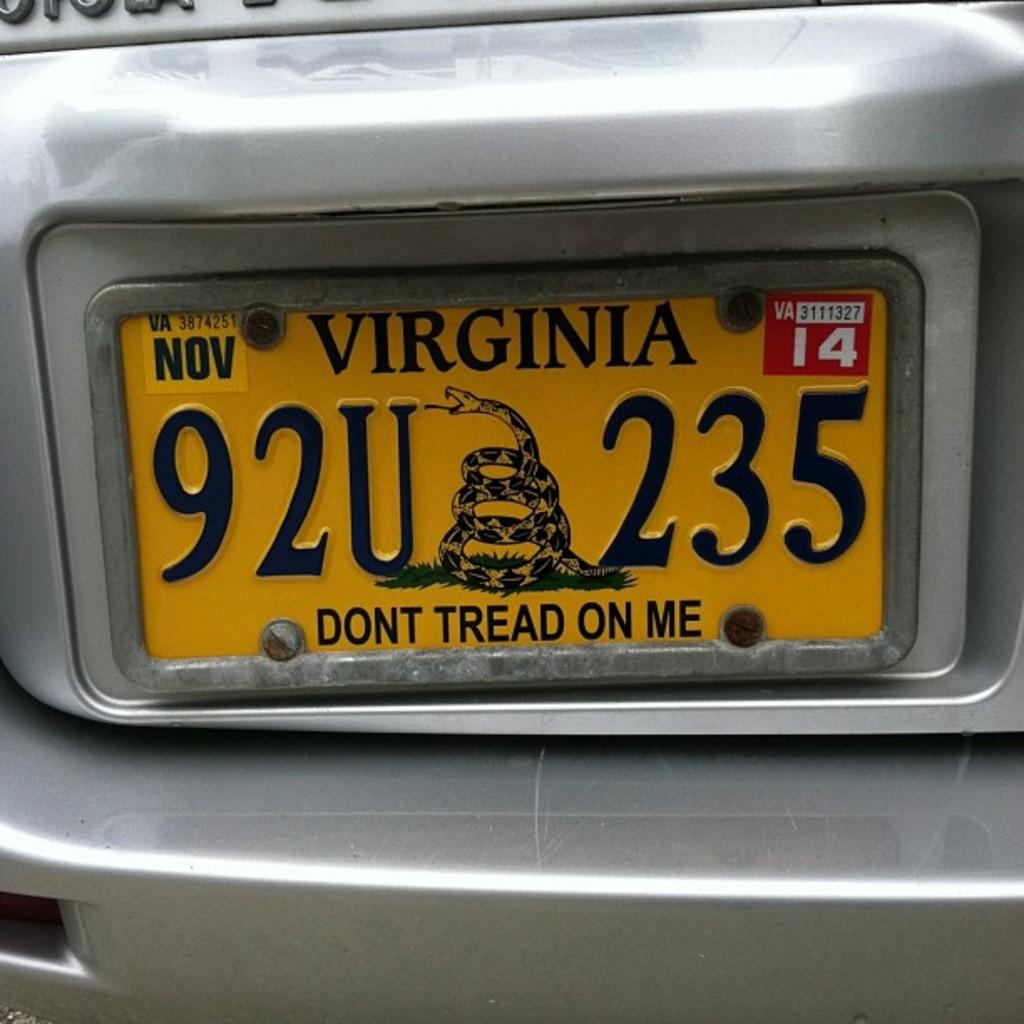<image>
Give a short and clear explanation of the subsequent image. A "Don't Tread On Me" Virginia license plate. 